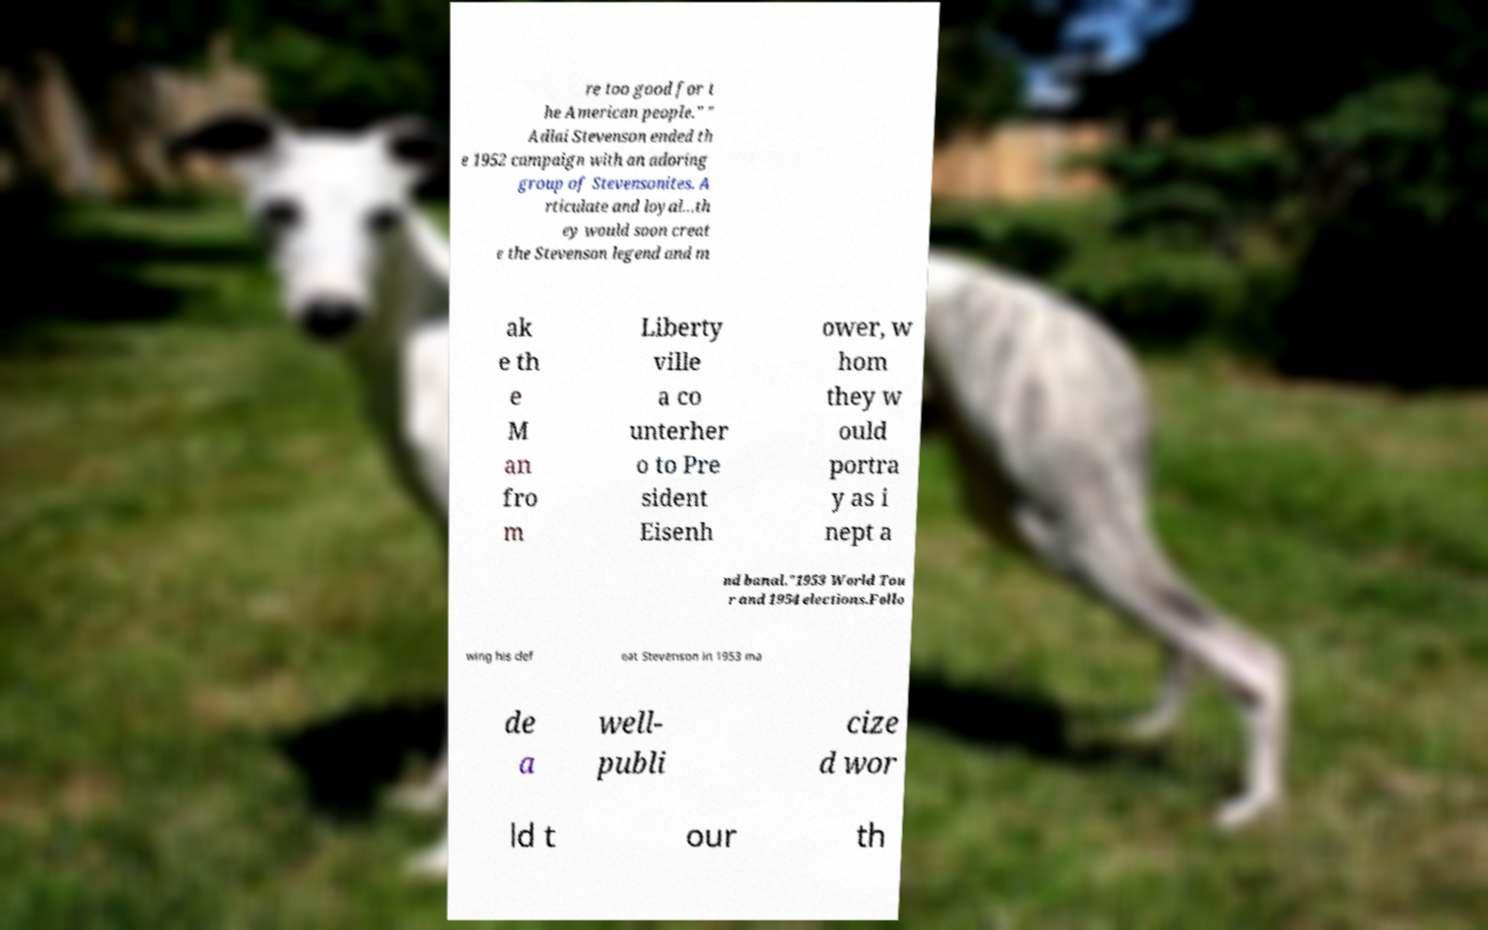Could you extract and type out the text from this image? re too good for t he American people." " Adlai Stevenson ended th e 1952 campaign with an adoring group of Stevensonites. A rticulate and loyal...th ey would soon creat e the Stevenson legend and m ak e th e M an fro m Liberty ville a co unterher o to Pre sident Eisenh ower, w hom they w ould portra y as i nept a nd banal."1953 World Tou r and 1954 elections.Follo wing his def eat Stevenson in 1953 ma de a well- publi cize d wor ld t our th 